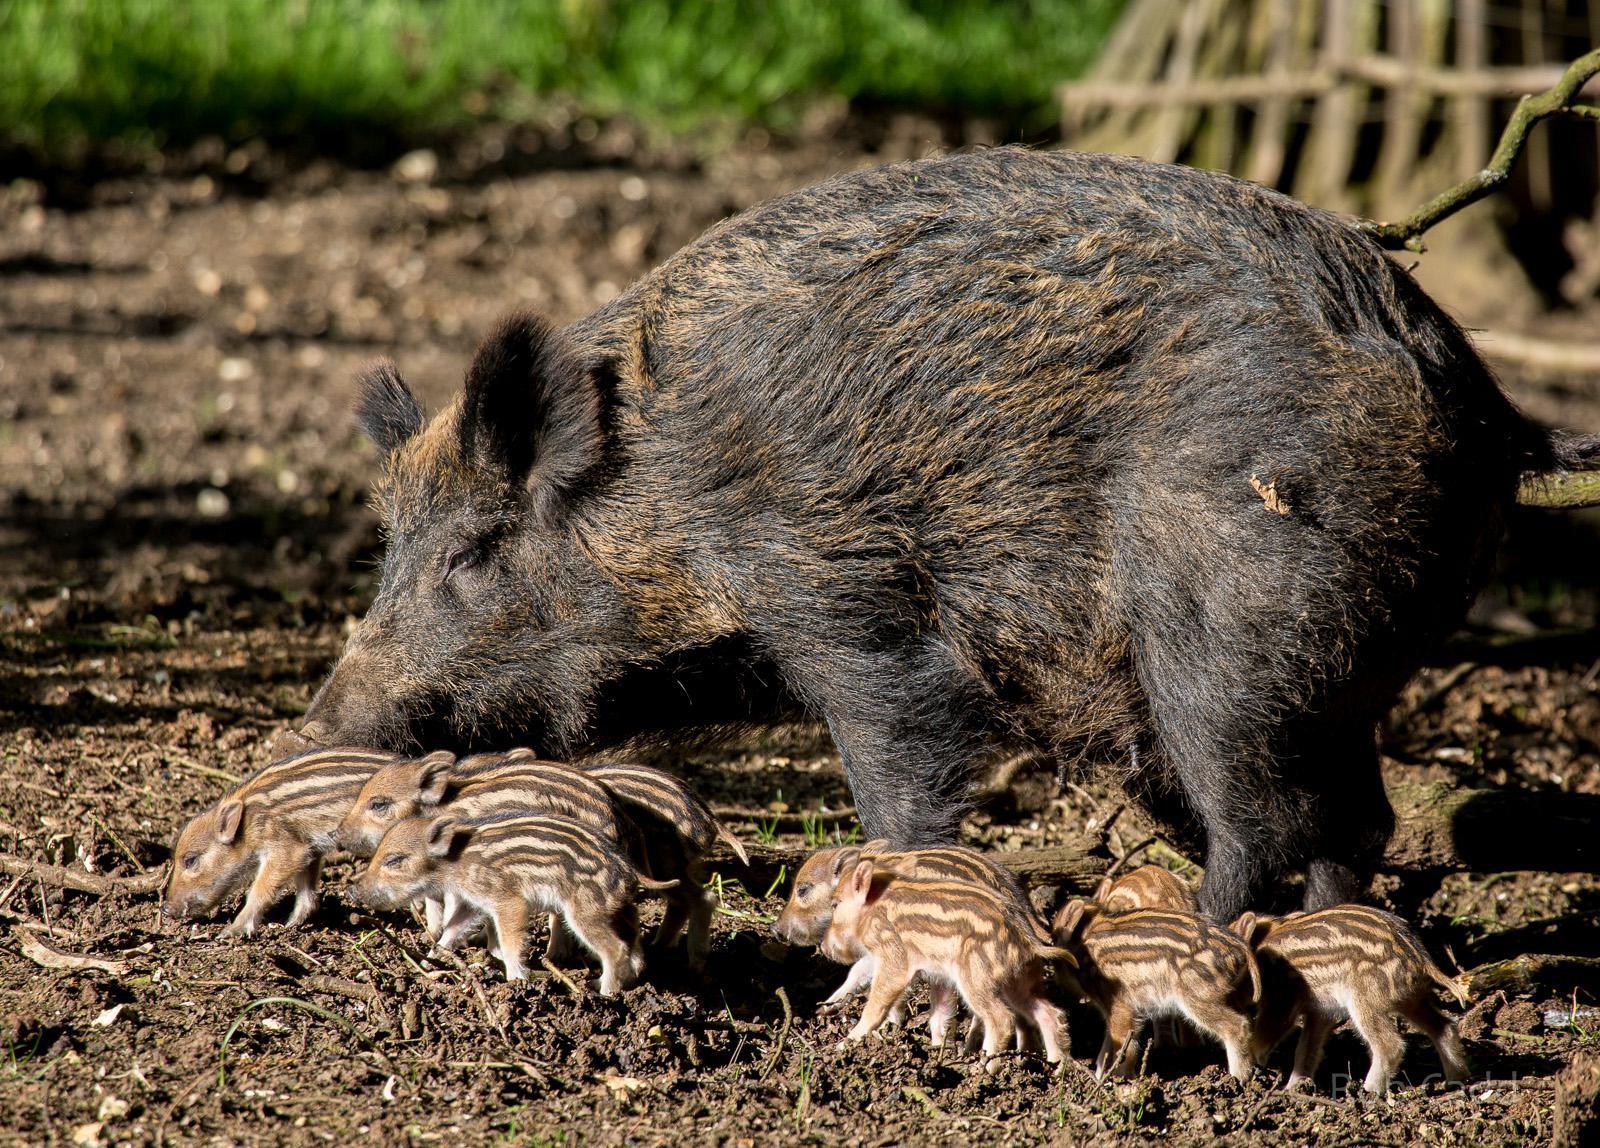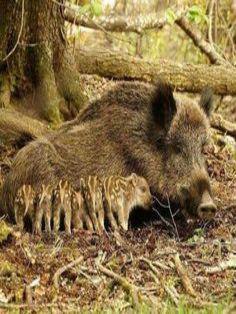The first image is the image on the left, the second image is the image on the right. For the images displayed, is the sentence "A mother warhog is rooting with her nose to the ground with her piglets near her" factually correct? Answer yes or no. Yes. The first image is the image on the left, the second image is the image on the right. Considering the images on both sides, is "In the right image, there's a wild boar with her piglets." valid? Answer yes or no. Yes. 